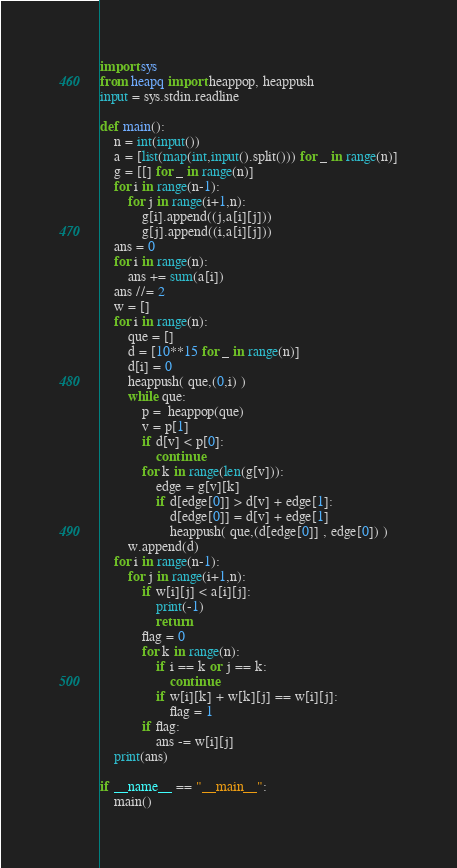<code> <loc_0><loc_0><loc_500><loc_500><_Python_>import sys
from heapq import heappop, heappush
input = sys.stdin.readline

def main():
    n = int(input())
    a = [list(map(int,input().split())) for _ in range(n)]
    g = [[] for _ in range(n)]
    for i in range(n-1):
        for j in range(i+1,n):
            g[i].append((j,a[i][j]))
            g[j].append((i,a[i][j]))
    ans = 0
    for i in range(n):
        ans += sum(a[i])
    ans //= 2
    w = []
    for i in range(n):
        que = []
        d = [10**15 for _ in range(n)]
        d[i] = 0
        heappush( que,(0,i) )
        while que:
            p =  heappop(que)
            v = p[1]
            if d[v] < p[0]:
                continue
            for k in range(len(g[v])):
                edge = g[v][k]
                if d[edge[0]] > d[v] + edge[1]:
                    d[edge[0]] = d[v] + edge[1]
                    heappush( que,(d[edge[0]] , edge[0]) )
        w.append(d)
    for i in range(n-1):
        for j in range(i+1,n):
            if w[i][j] < a[i][j]:
                print(-1)
                return
            flag = 0
            for k in range(n):
                if i == k or j == k:
                    continue
                if w[i][k] + w[k][j] == w[i][j]:
                    flag = 1
            if flag:
                ans -= w[i][j]
    print(ans)

if __name__ == "__main__":
    main()</code> 